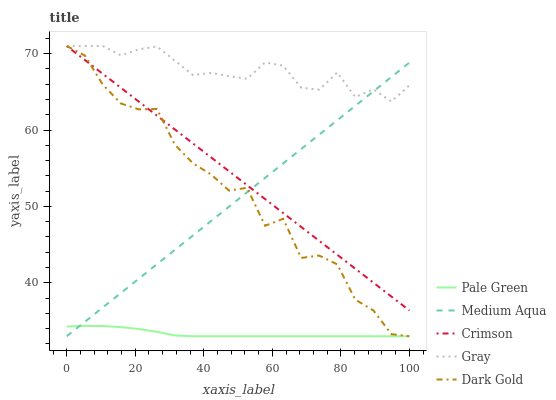Does Gray have the minimum area under the curve?
Answer yes or no. No. Does Pale Green have the maximum area under the curve?
Answer yes or no. No. Is Gray the smoothest?
Answer yes or no. No. Is Gray the roughest?
Answer yes or no. No. Does Gray have the lowest value?
Answer yes or no. No. Does Pale Green have the highest value?
Answer yes or no. No. Is Pale Green less than Crimson?
Answer yes or no. Yes. Is Crimson greater than Pale Green?
Answer yes or no. Yes. Does Pale Green intersect Crimson?
Answer yes or no. No. 